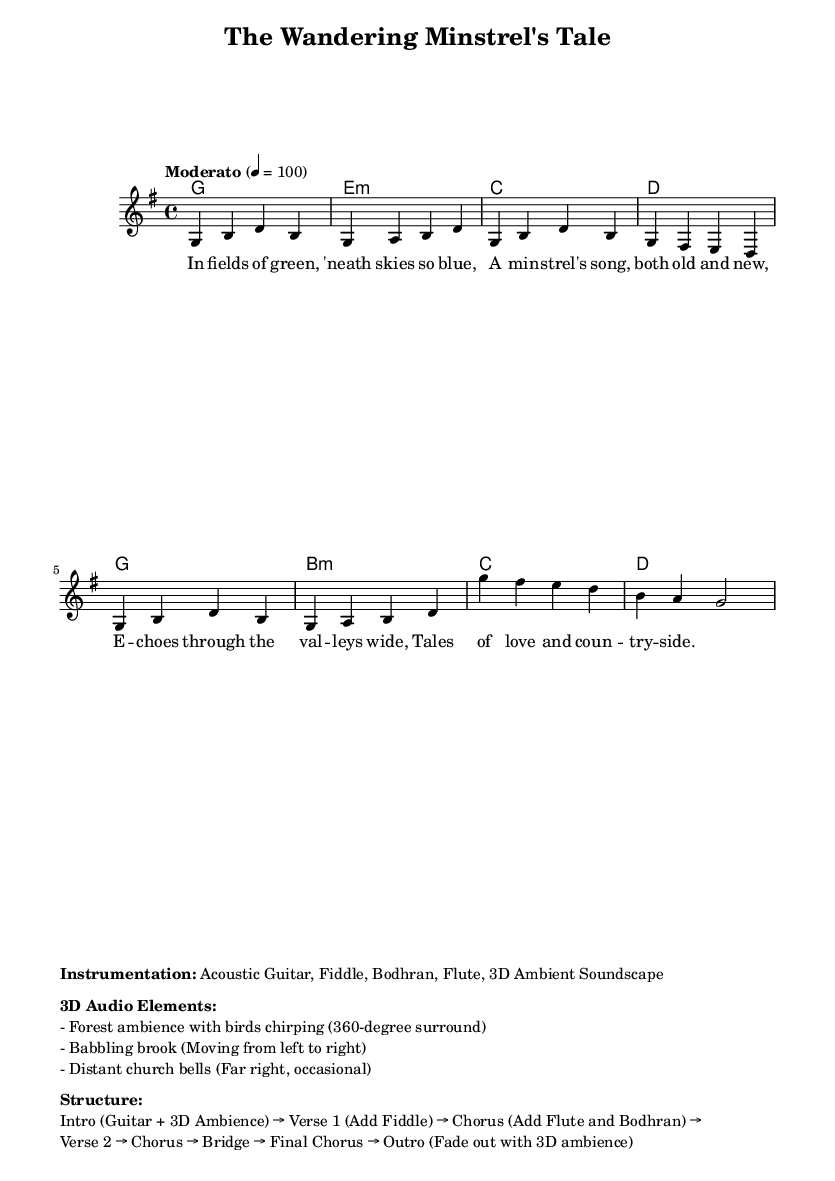What is the tempo marking of this music? The tempo marking is indicated by "Moderato" and specifies a beats per minute count of 100, which denotes a moderate pace.
Answer: Moderato What is the key signature of this piece? The music is written in the key of G major, which has one sharp (F#) in its key signature.
Answer: G major How many measures are in the melody section? The melody section consists of 8 measures, each defined by the vertical bar lines.
Answer: 8 What are the first two instruments listed in the instrumentation? The instrumentation includes Acoustic Guitar and Fiddle as the first two instruments listed, emphasized by their placement at the beginning of the section.
Answer: Acoustic Guitar, Fiddle What is the structure of the piece? The structure outlines the flow of the music starting with an Intro followed by verses and choruses, guiding the listener through a dynamic progression, ending with an Outro.
Answer: Intro → Verse 1 → Chorus → Verse 2 → Chorus → Bridge → Final Chorus → Outro What is the specific role of the 3D audio elements in this music? The 3D audio elements enhance the immersive experience by adding spatial ambience, with sounds such as birds chirping and a babbling brook, creating an engaging auditory environment.
Answer: Enhance immersive experience What genre does "The Wandering Minstrel's Tale" belong to? The title indicates that this piece is a traditional folk ballad, characterized by storytelling and folk themes, aligning with the genre's typical elements.
Answer: Folk 